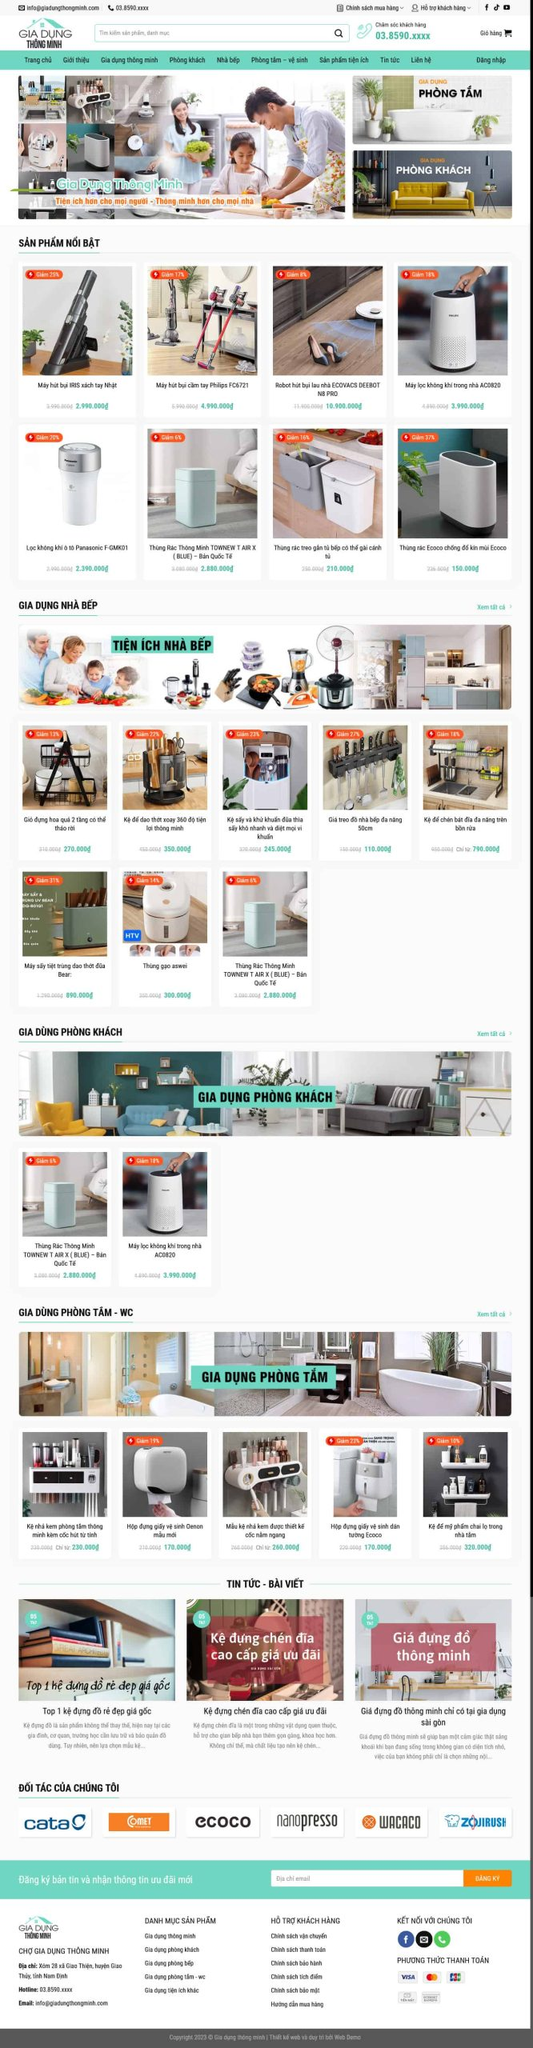Liệt kê 5 ngành nghề, lĩnh vực phù hợp với website này, phân cách các màu sắc bằng dấu phẩy. Chỉ trả về kết quả, phân cách bằng dấy phẩy
 Đồ gia dụng, Đồ thông minh, Thiết bị nhà bếp, Thiết bị vệ sinh, Thiết bị phòng khách 